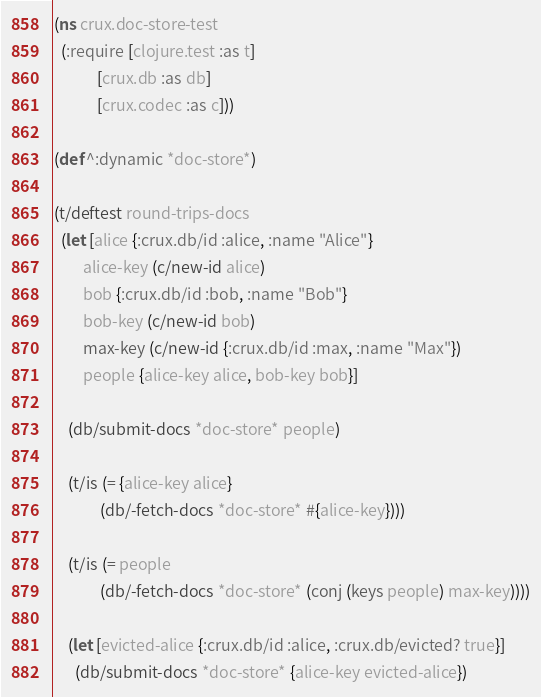Convert code to text. <code><loc_0><loc_0><loc_500><loc_500><_Clojure_>(ns crux.doc-store-test
  (:require [clojure.test :as t]
            [crux.db :as db]
            [crux.codec :as c]))

(def ^:dynamic *doc-store*)

(t/deftest round-trips-docs
  (let [alice {:crux.db/id :alice, :name "Alice"}
        alice-key (c/new-id alice)
        bob {:crux.db/id :bob, :name "Bob"}
        bob-key (c/new-id bob)
        max-key (c/new-id {:crux.db/id :max, :name "Max"})
        people {alice-key alice, bob-key bob}]

    (db/submit-docs *doc-store* people)

    (t/is (= {alice-key alice}
             (db/-fetch-docs *doc-store* #{alice-key})))

    (t/is (= people
             (db/-fetch-docs *doc-store* (conj (keys people) max-key))))

    (let [evicted-alice {:crux.db/id :alice, :crux.db/evicted? true}]
      (db/submit-docs *doc-store* {alice-key evicted-alice})
</code> 